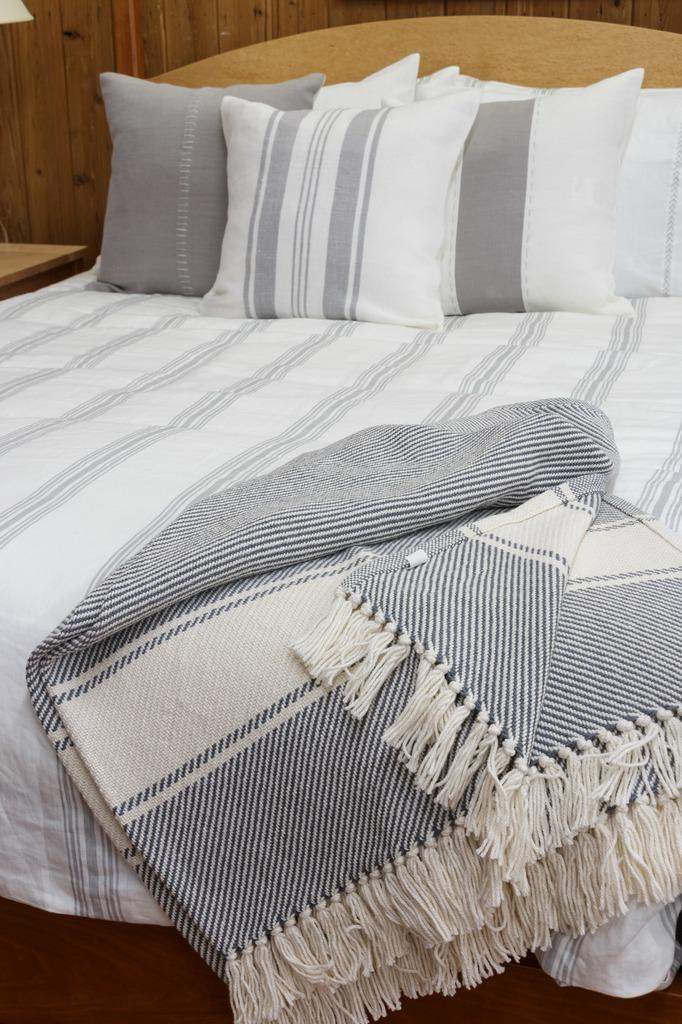What piece of furniture is present in the image? There is a bed in the image. What accessories are on the bed? The bed has pillows and a blanket on it. What type of material is visible in the background of the image? There is a wooden wall in the background of the image. How many dolls are sitting on the wooden wall in the image? There are no dolls present in the image; it only features a bed with pillows and a blanket, and a wooden wall in the background. 